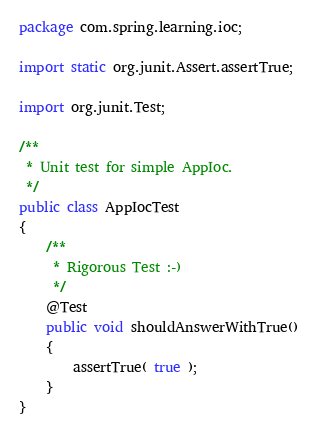<code> <loc_0><loc_0><loc_500><loc_500><_Java_>package com.spring.learning.ioc;

import static org.junit.Assert.assertTrue;

import org.junit.Test;

/**
 * Unit test for simple AppIoc.
 */
public class AppIocTest
{
    /**
     * Rigorous Test :-)
     */
    @Test
    public void shouldAnswerWithTrue()
    {
        assertTrue( true );
    }
}
</code> 